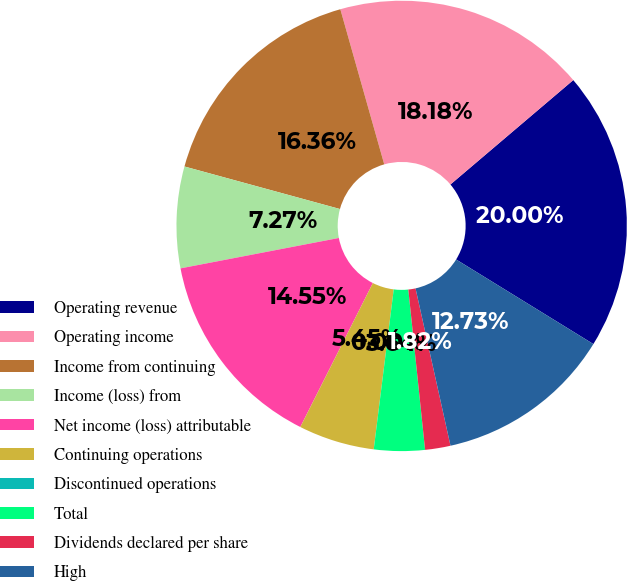<chart> <loc_0><loc_0><loc_500><loc_500><pie_chart><fcel>Operating revenue<fcel>Operating income<fcel>Income from continuing<fcel>Income (loss) from<fcel>Net income (loss) attributable<fcel>Continuing operations<fcel>Discontinued operations<fcel>Total<fcel>Dividends declared per share<fcel>High<nl><fcel>20.0%<fcel>18.18%<fcel>16.36%<fcel>7.27%<fcel>14.55%<fcel>5.45%<fcel>0.0%<fcel>3.64%<fcel>1.82%<fcel>12.73%<nl></chart> 